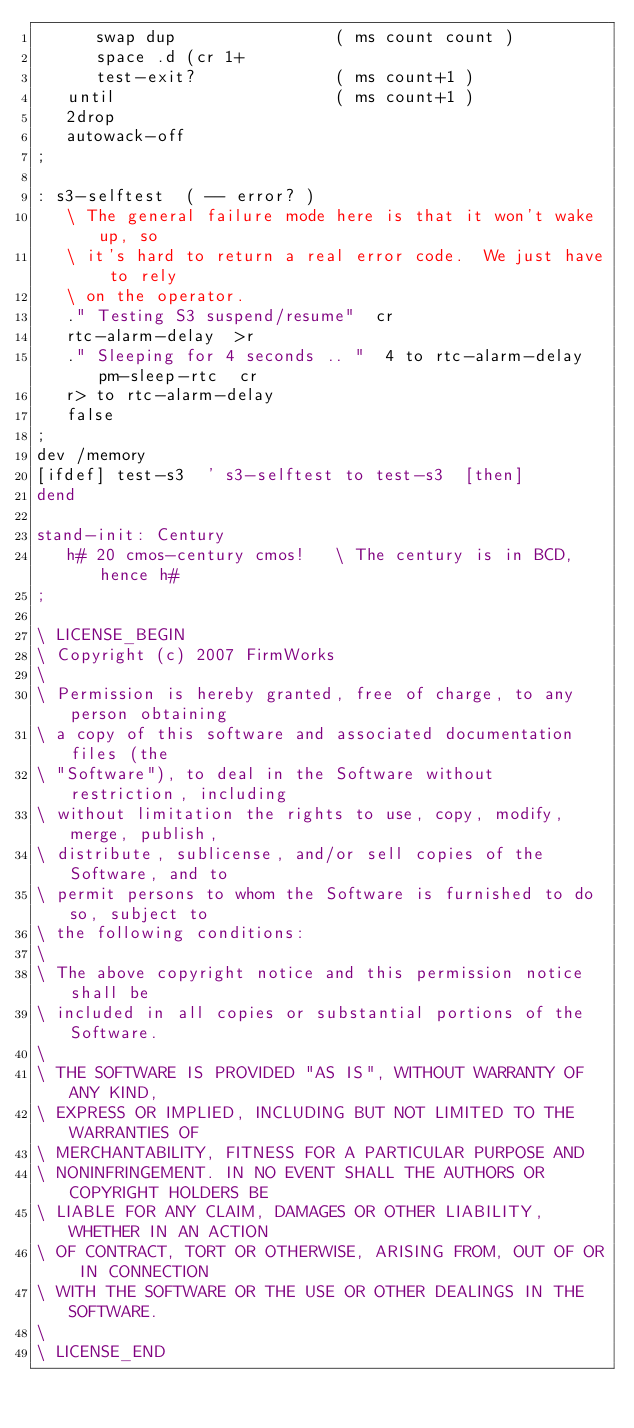<code> <loc_0><loc_0><loc_500><loc_500><_Forth_>      swap dup                ( ms count count )
      space .d (cr 1+ 
      test-exit?              ( ms count+1 )
   until                      ( ms count+1 )
   2drop
   autowack-off
;

: s3-selftest  ( -- error? )
   \ The general failure mode here is that it won't wake up, so
   \ it's hard to return a real error code.  We just have to rely
   \ on the operator.
   ." Testing S3 suspend/resume"  cr
   rtc-alarm-delay  >r
   ." Sleeping for 4 seconds .. "  4 to rtc-alarm-delay  pm-sleep-rtc  cr
   r> to rtc-alarm-delay
   false
;
dev /memory
[ifdef] test-s3  ' s3-selftest to test-s3  [then]
dend

stand-init: Century
   h# 20 cmos-century cmos!   \ The century is in BCD, hence h#
;

\ LICENSE_BEGIN
\ Copyright (c) 2007 FirmWorks
\ 
\ Permission is hereby granted, free of charge, to any person obtaining
\ a copy of this software and associated documentation files (the
\ "Software"), to deal in the Software without restriction, including
\ without limitation the rights to use, copy, modify, merge, publish,
\ distribute, sublicense, and/or sell copies of the Software, and to
\ permit persons to whom the Software is furnished to do so, subject to
\ the following conditions:
\ 
\ The above copyright notice and this permission notice shall be
\ included in all copies or substantial portions of the Software.
\ 
\ THE SOFTWARE IS PROVIDED "AS IS", WITHOUT WARRANTY OF ANY KIND,
\ EXPRESS OR IMPLIED, INCLUDING BUT NOT LIMITED TO THE WARRANTIES OF
\ MERCHANTABILITY, FITNESS FOR A PARTICULAR PURPOSE AND
\ NONINFRINGEMENT. IN NO EVENT SHALL THE AUTHORS OR COPYRIGHT HOLDERS BE
\ LIABLE FOR ANY CLAIM, DAMAGES OR OTHER LIABILITY, WHETHER IN AN ACTION
\ OF CONTRACT, TORT OR OTHERWISE, ARISING FROM, OUT OF OR IN CONNECTION
\ WITH THE SOFTWARE OR THE USE OR OTHER DEALINGS IN THE SOFTWARE.
\
\ LICENSE_END
</code> 